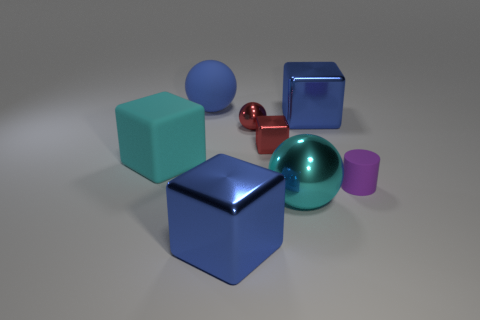What is the material of the large sphere that is the same color as the large rubber block?
Your response must be concise. Metal. Is there anything else that is the same shape as the purple thing?
Provide a succinct answer. No. How many things are either green things or small rubber objects?
Make the answer very short. 1. There is a matte thing that is the same shape as the cyan metallic object; what is its size?
Provide a succinct answer. Large. What number of other objects are there of the same color as the tiny shiny ball?
Your answer should be compact. 1. What number of cylinders are either big blue matte things or big cyan rubber things?
Ensure brevity in your answer.  0. What is the color of the large sphere that is behind the large shiny block behind the purple rubber cylinder?
Make the answer very short. Blue. What shape is the blue rubber thing?
Keep it short and to the point. Sphere. There is a cube left of the matte ball; does it have the same size as the small matte thing?
Your response must be concise. No. Is there a small purple cylinder that has the same material as the red block?
Ensure brevity in your answer.  No. 